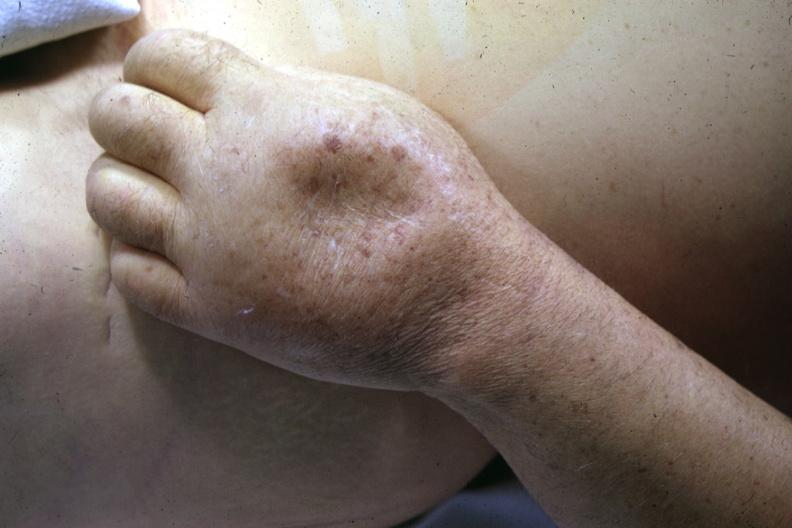how does this image show close-up of dorsum of hand?
Answer the question using a single word or phrase. With marked pitting edema good example 